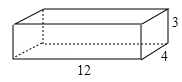Let's consider a wooden box with dimensions of length, width, and height as variables 'l', 'w', and 'h' respectively (l = 12.0, w = 4.0, h = 3.0). What is the maximum length of a thin wooden strip that can be placed inside the box without protruding? Express the maximum length as 'x' in terms of 'l', 'w', and 'h'. Choices: A: 13cm B: 14cm C: 15cm D: 16cm To identify the maximum length 'x' for a thin wooden strip to fit within a rectangular box without protruding, we need to find the longest diagonal that runs from one corner to the opposite. In this scenario, imagine drawing a line from one corner of the interior of the box, say the bottom front left corner (let's call this point A), to the furthest opposite corner on the top back right (point D). To calculate this, we must first find the diagonal on the base of the box (line AC, connecting point A to the opposite corner on the same base C), using the box's length 'l' and width 'w', then apply the Pythagorean theorem. Next, we use the result as one leg of a new right triangle, where line AD is the hypotenuse and the height 'h' of the box is the other leg. The extensive calculation, using the given dimensions (l = 12.0, w = 4.0, h = 3.0), demonstrates that the maximum strip length is precisely 13 cm, which means our answer is option A. 